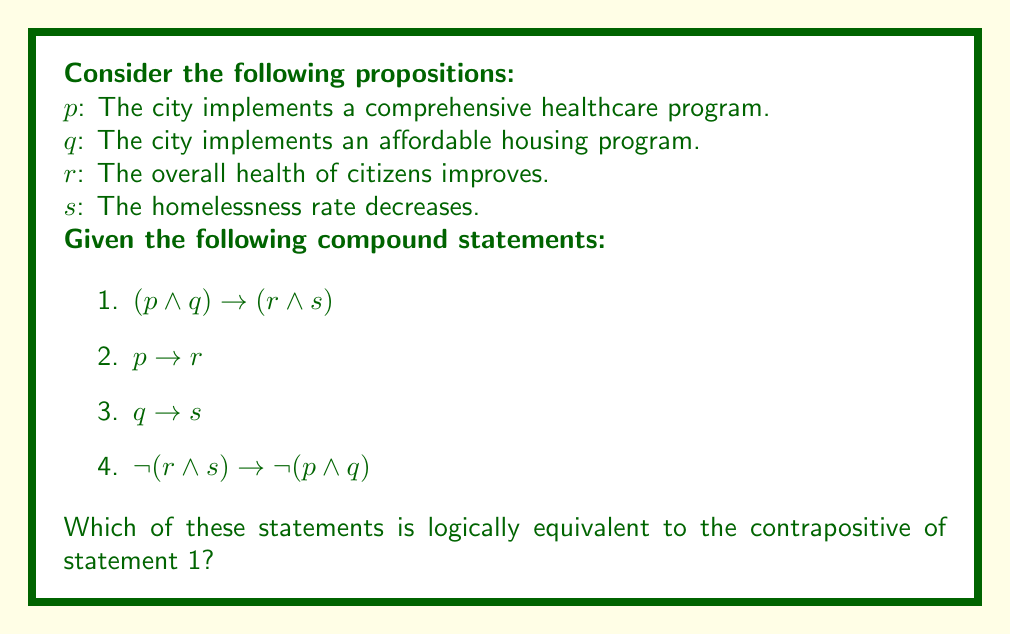Show me your answer to this math problem. To solve this problem, we need to follow these steps:

1. Identify the contrapositive of statement 1.
2. Simplify the contrapositive using logical equivalences.
3. Compare the result with the given statements to find a match.

Step 1: The contrapositive of $(p \land q) \rightarrow (r \land s)$

The contrapositive of $A \rightarrow B$ is $\lnot B \rightarrow \lnot A$. So, the contrapositive of statement 1 is:

$$\lnot (r \land s) \rightarrow \lnot (p \land q)$$

Step 2: Simplification

This contrapositive is already in its simplest form.

Step 3: Comparison

Looking at the given statements, we can see that statement 4 is identical to the contrapositive we derived:

$$\lnot (r \land s) \rightarrow \lnot (p \land q)$$

Therefore, statement 4 is logically equivalent to the contrapositive of statement 1.

This result is particularly relevant for a local government official concerned with health and social services. It suggests that if either the overall health of citizens does not improve or the homelessness rate does not decrease (or both), then it implies that the city has not implemented both the comprehensive healthcare program and the affordable housing program.
Answer: Statement 4: $\lnot (r \land s) \rightarrow \lnot (p \land q)$ 